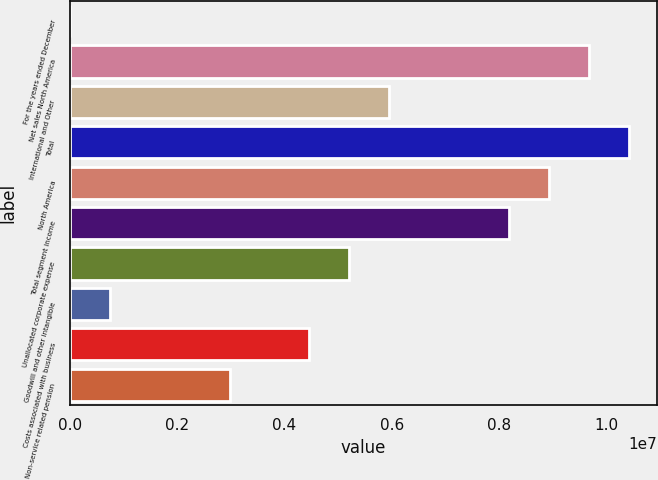Convert chart to OTSL. <chart><loc_0><loc_0><loc_500><loc_500><bar_chart><fcel>For the years ended December<fcel>Net sales North America<fcel>International and Other<fcel>Total<fcel>North America<fcel>Total segment income<fcel>Unallocated corporate expense<fcel>Goodwill and other intangible<fcel>Costs associated with business<fcel>Non-service related pension<nl><fcel>2016<fcel>9.67163e+06<fcel>5.95255e+06<fcel>1.04154e+07<fcel>8.92781e+06<fcel>8.184e+06<fcel>5.20873e+06<fcel>745832<fcel>4.46492e+06<fcel>2.97728e+06<nl></chart> 